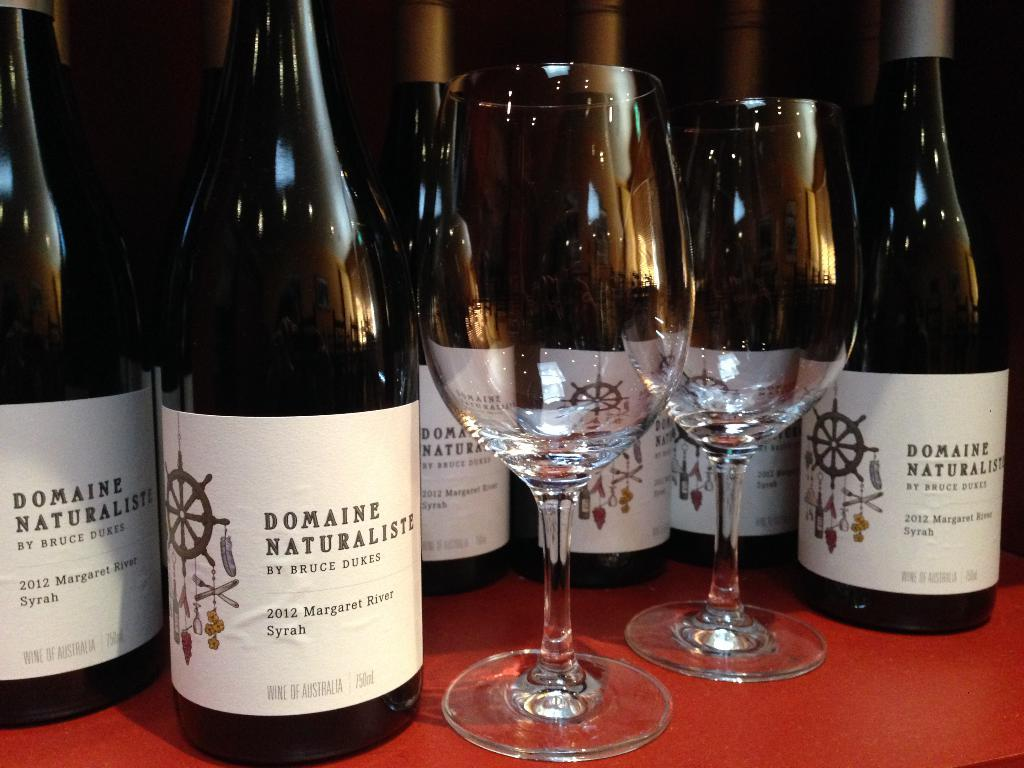Provide a one-sentence caption for the provided image. The two crystal wineglasses are displayed with six bottles of Domaine Naturaliste wine in the background. 